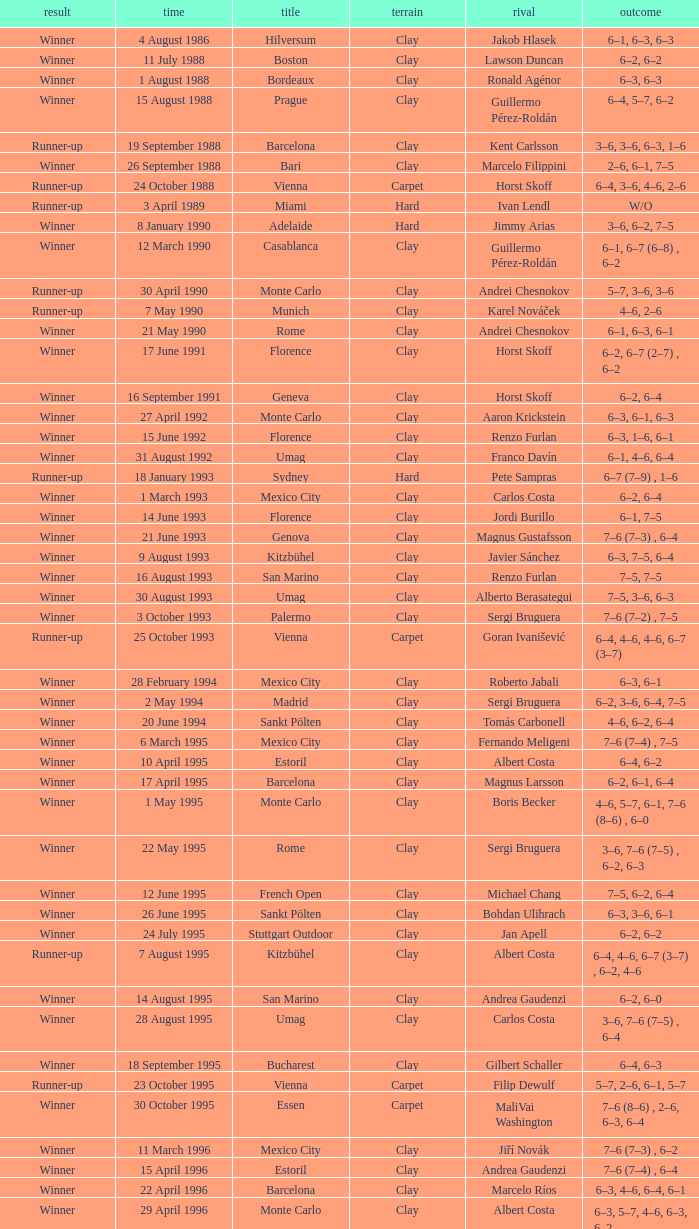What is the score when the outcome is winner against yevgeny kafelnikov? 6–2, 6–2, 6–4. 